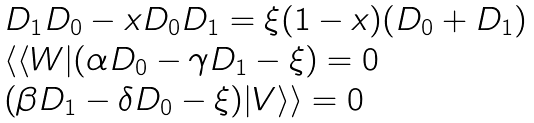Convert formula to latex. <formula><loc_0><loc_0><loc_500><loc_500>\begin{array} { l } D _ { 1 } D _ { 0 } - x D _ { 0 } D _ { 1 } = \xi ( 1 - x ) ( D _ { 0 } + D _ { 1 } ) \\ \langle \langle W | ( \alpha D _ { 0 } - \gamma D _ { 1 } - \xi ) = 0 \\ ( \beta D _ { 1 } - \delta D _ { 0 } - \xi ) | V \rangle \rangle = 0 \end{array}</formula> 